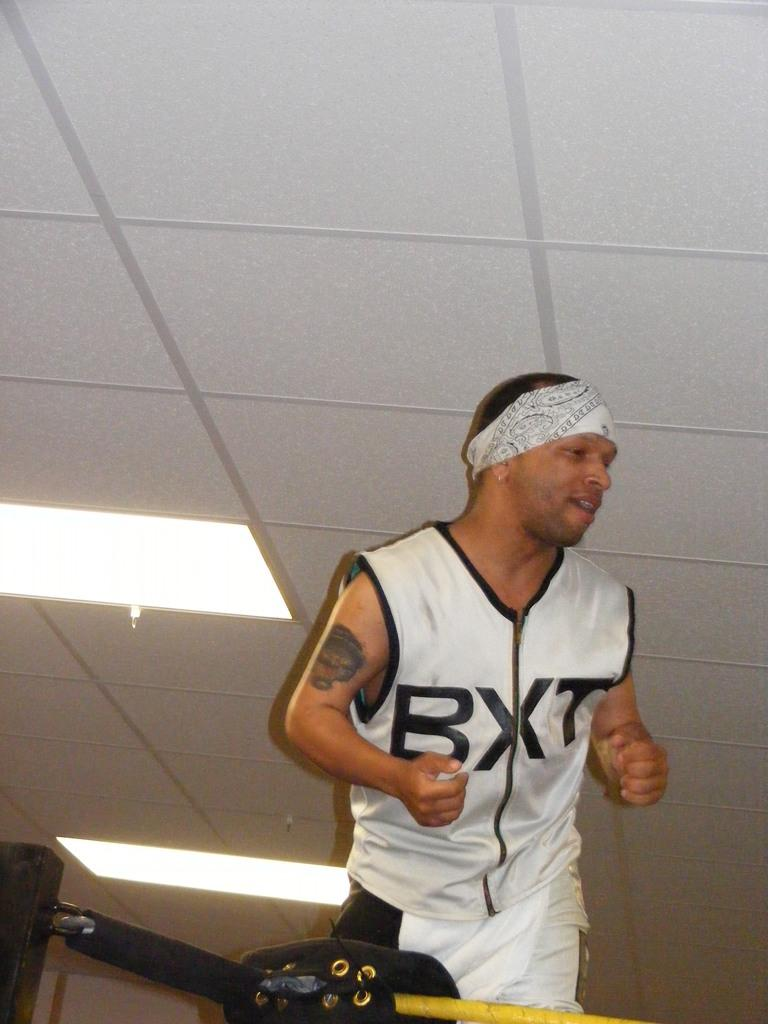<image>
Present a compact description of the photo's key features. A man with a white top with the letters BXT on it also wears a bandana 